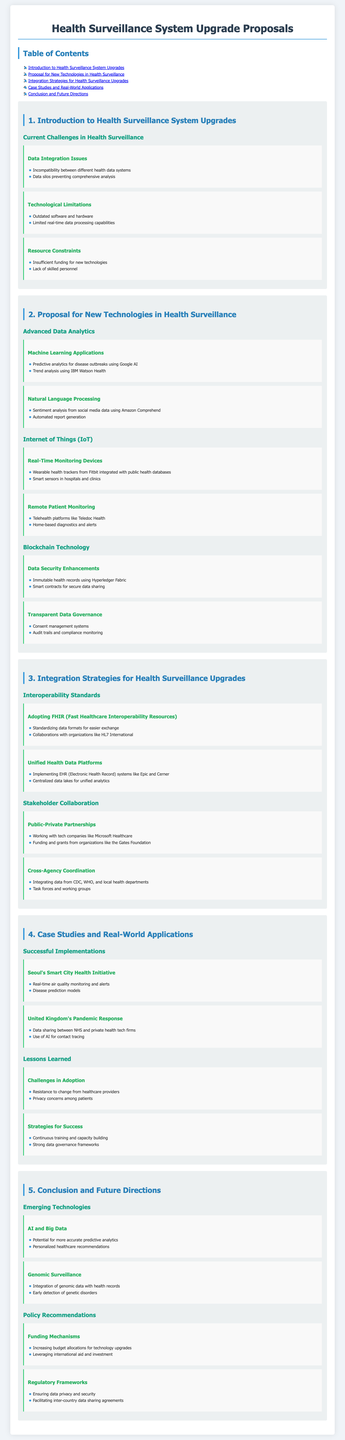What are the current challenges in health surveillance? The document lists several challenges including data integration issues, technological limitations, and resource constraints.
Answer: Data integration issues, technological limitations, resource constraints What technology is proposed for predictive analytics? The document mentions machine learning applications like predictive analytics for disease outbreaks using Google AI.
Answer: Google AI What is one of the proposed uses of IoT in health surveillance? The document states that real-time monitoring devices like wearable health trackers from Fitbit will be integrated with public health databases.
Answer: Wearable health trackers from Fitbit Which interoperability standard is recommended? The document recommends adopting FHIR (Fast Healthcare Interoperability Resources) for standardizing data formats.
Answer: FHIR What case study is cited for successful health initiative implementation? The document includes Seoul's Smart City Health Initiative as a successful case study.
Answer: Seoul's Smart City Health Initiative What is a key factor for success mentioned in the lessons learned? The document emphasizes continuous training and capacity building as a critical strategy for success.
Answer: Continuous training and capacity building How many sections are in the document? The document contains five main sections outlined in the Table of Contents.
Answer: Five What type of technology is used for data security enhancements? Blockchain technology is suggested for enhancing data security through immutable health records.
Answer: Blockchain technology Which organization is mentioned in public-private partnerships? The document notes collaboration with tech companies like Microsoft Healthcare in public-private partnerships.
Answer: Microsoft Healthcare 